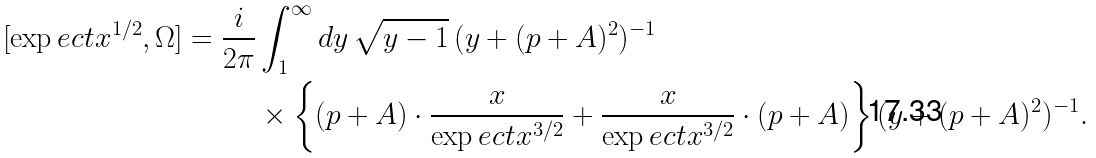Convert formula to latex. <formula><loc_0><loc_0><loc_500><loc_500>[ \exp e c t { x } ^ { 1 / 2 } , \Omega ] = \frac { i } { 2 \pi } & \int _ { 1 } ^ { \infty } d y \, \sqrt { y - 1 } \, ( y + ( p + A ) ^ { 2 } ) ^ { - 1 } \\ & \times \left \{ ( p + A ) \cdot \frac { x } { \exp e c t { x } ^ { 3 / 2 } } + \frac { x } { \exp e c t { x } ^ { 3 / 2 } } \cdot ( p + A ) \right \} ( y + ( p + A ) ^ { 2 } ) ^ { - 1 } .</formula> 